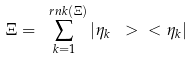Convert formula to latex. <formula><loc_0><loc_0><loc_500><loc_500>\Xi = \sum _ { k = 1 } ^ { \ r n k ( \Xi ) } | \eta _ { k } \ > \ < \eta _ { k } |</formula> 